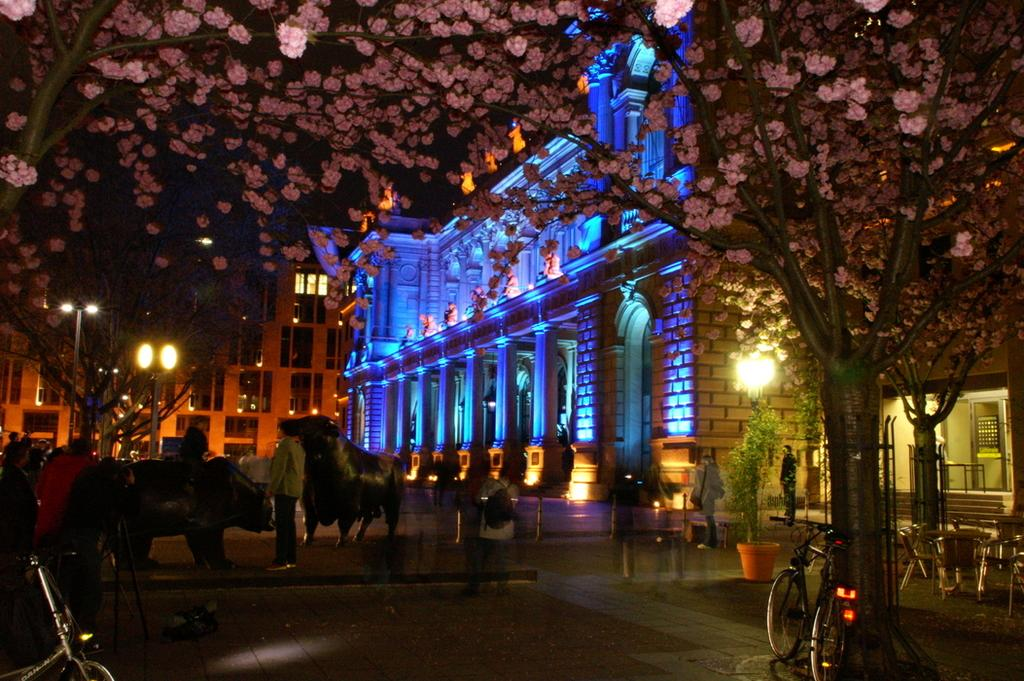What type of vegetation is visible at the top side of the image? There are trees at the top side of the image. What type of structures are located in the center of the image? There are buildings in the center of the image. What mode of transportation can be seen on the right side of the image? There are bicycles on the right side of the image. What mode of transportation can be seen on the left side of the image? There are bicycles on the left side of the image. What type of metal is used to cook the beef in the image? There is no metal or beef present in the image; it features trees, buildings, and bicycles. 